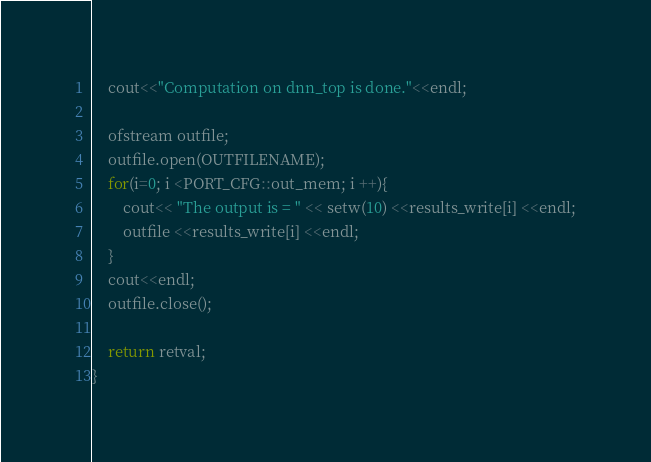Convert code to text. <code><loc_0><loc_0><loc_500><loc_500><_C++_>


	cout<<"Computation on dnn_top is done."<<endl;

	ofstream outfile;
	outfile.open(OUTFILENAME);
	for(i=0; i <PORT_CFG::out_mem; i ++){
		cout<< "The output is = " << setw(10) <<results_write[i] <<endl;
		outfile <<results_write[i] <<endl;
	}
	cout<<endl;
	outfile.close();

	return retval;
}
</code> 